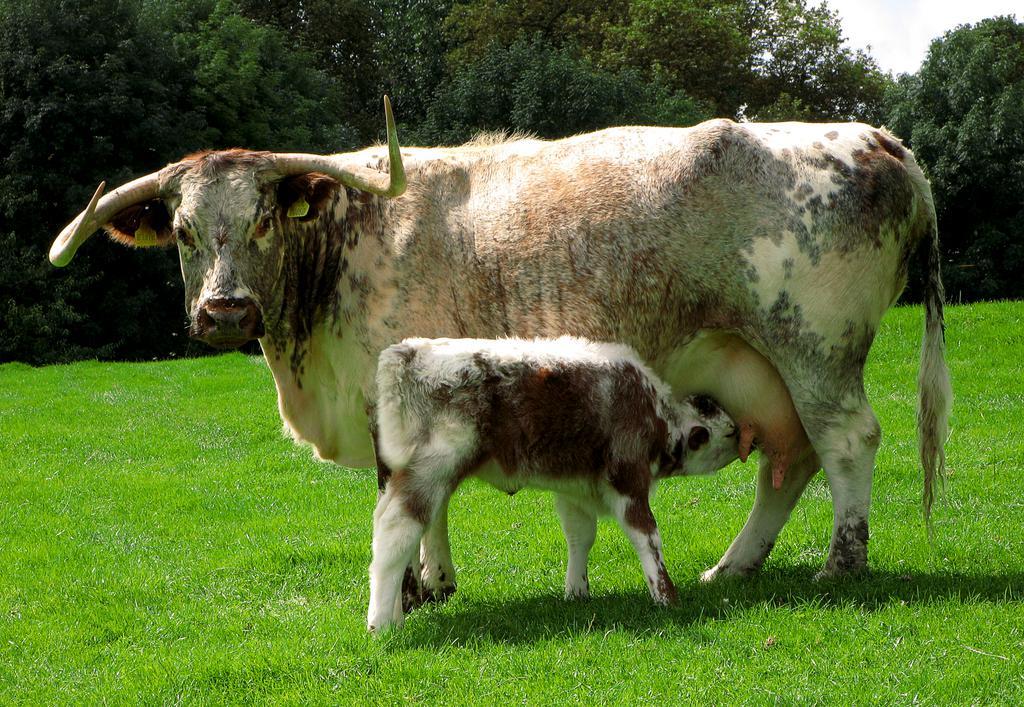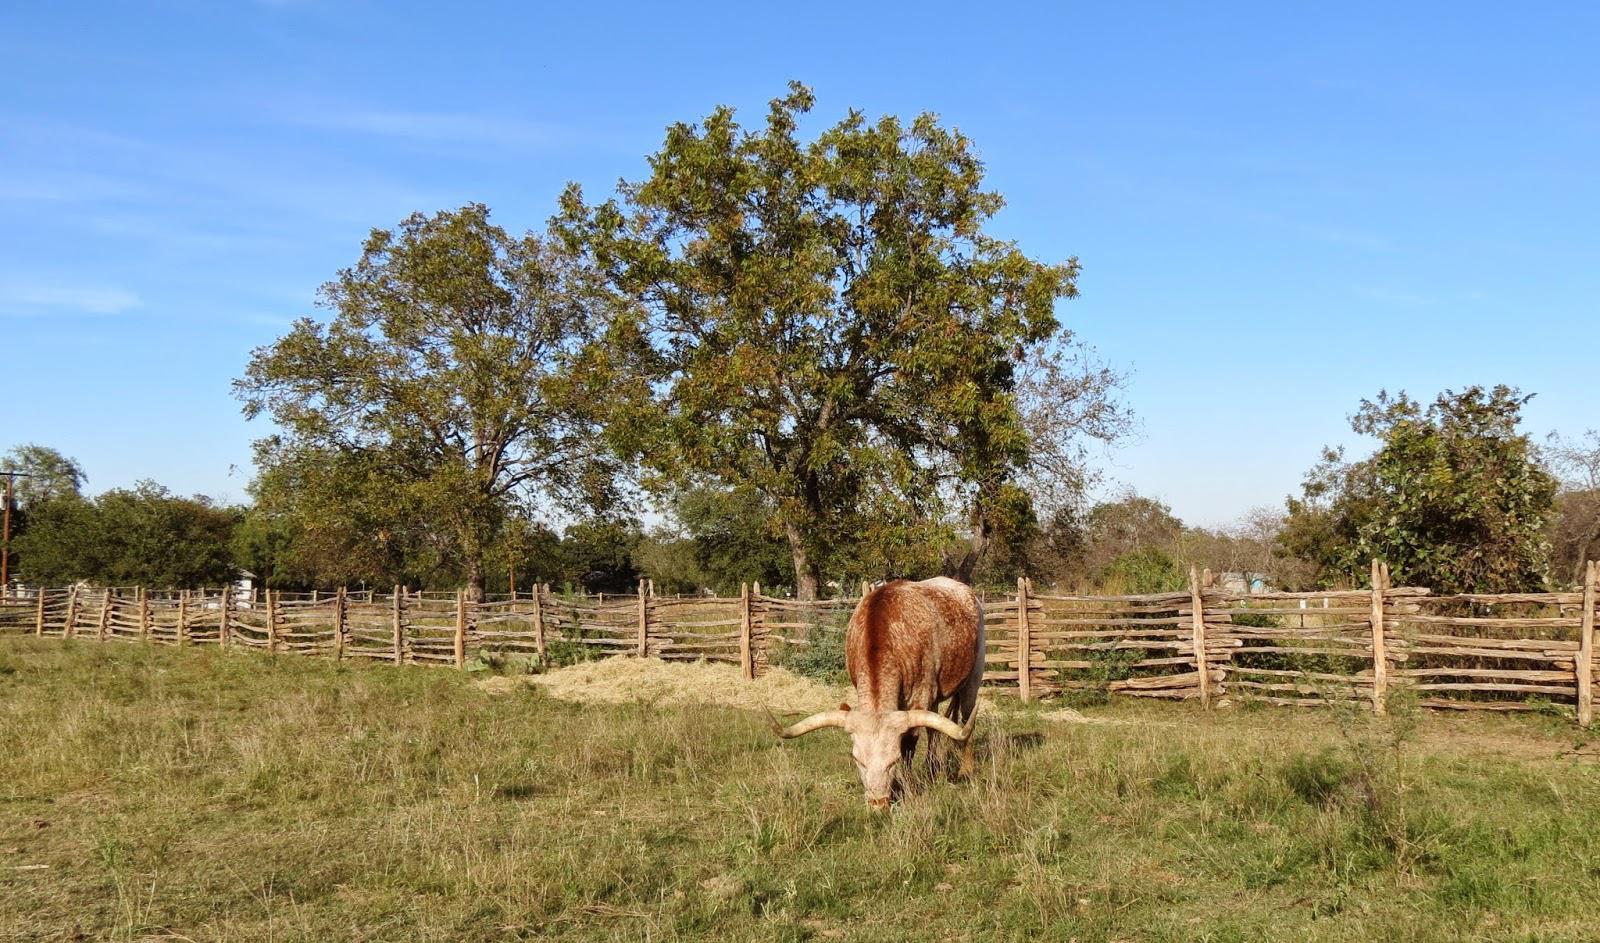The first image is the image on the left, the second image is the image on the right. For the images displayed, is the sentence "Each image contains one hooved animal standing in profile, each animal is an adult cow with horns, and the animals on the left and right have their bodies turned in the same direction." factually correct? Answer yes or no. No. The first image is the image on the left, the second image is the image on the right. Assess this claim about the two images: "One large animal is eating grass near a pond.". Correct or not? Answer yes or no. No. 